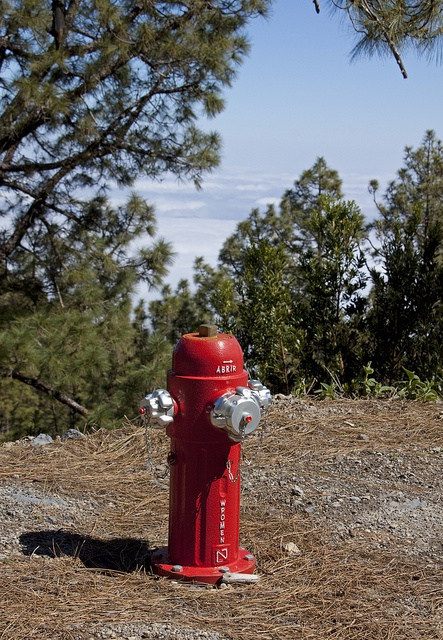Describe the objects in this image and their specific colors. I can see a fire hydrant in black, brown, maroon, and gray tones in this image. 